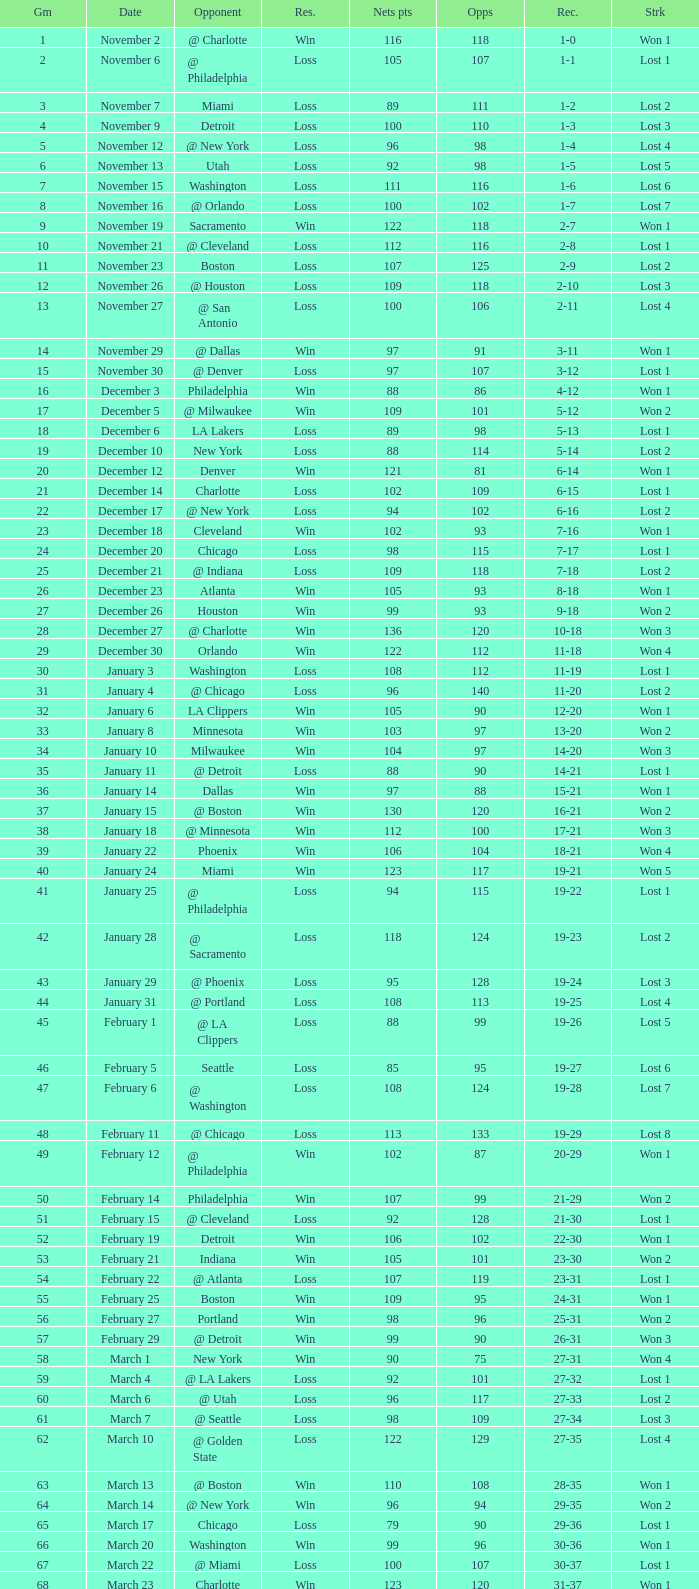How many opponents were there in a game higher than 20 on January 28? 124.0. 